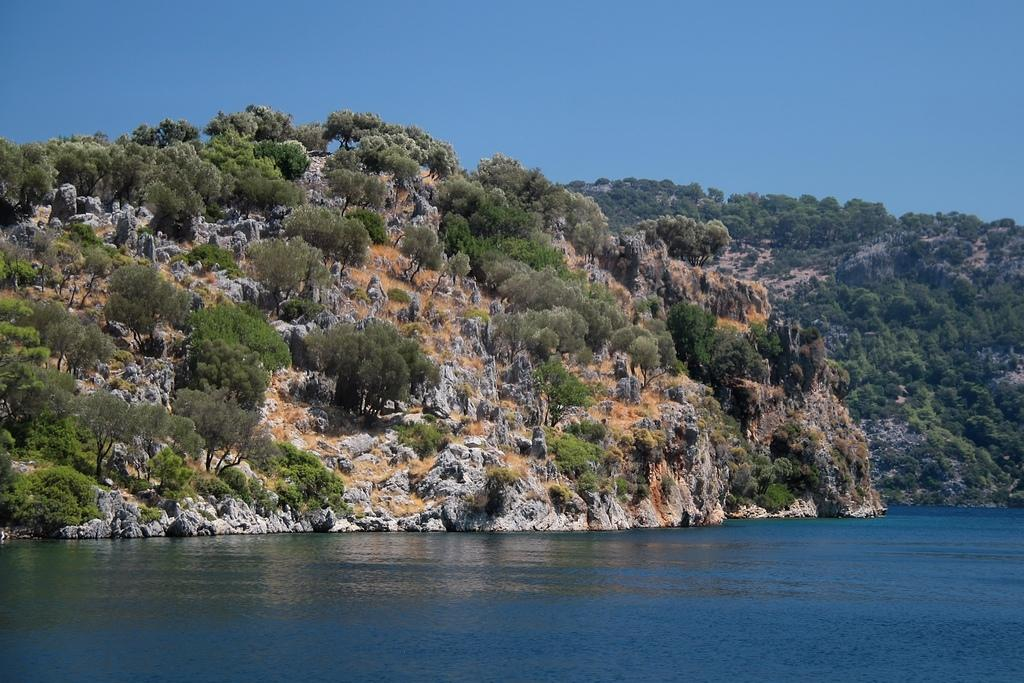What is the primary element present in the image? The image contains water. What type of vegetation can be seen in the image? There are trees in the image. What geographical feature is visible in the image? There is a mountain in the image. What is visible in the background of the image? The sky is visible in the background of the image. How many centimeters tall is the lawyer standing next to the mountain in the image? There is no lawyer present in the image, so it is not possible to determine their height. 